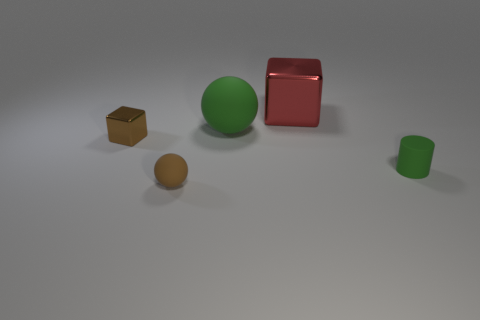Add 3 small brown rubber balls. How many objects exist? 8 Subtract all cubes. How many objects are left? 3 Subtract all tiny blue matte cubes. Subtract all brown metallic blocks. How many objects are left? 4 Add 4 big cubes. How many big cubes are left? 5 Add 2 large cyan rubber things. How many large cyan rubber things exist? 2 Subtract 1 brown spheres. How many objects are left? 4 